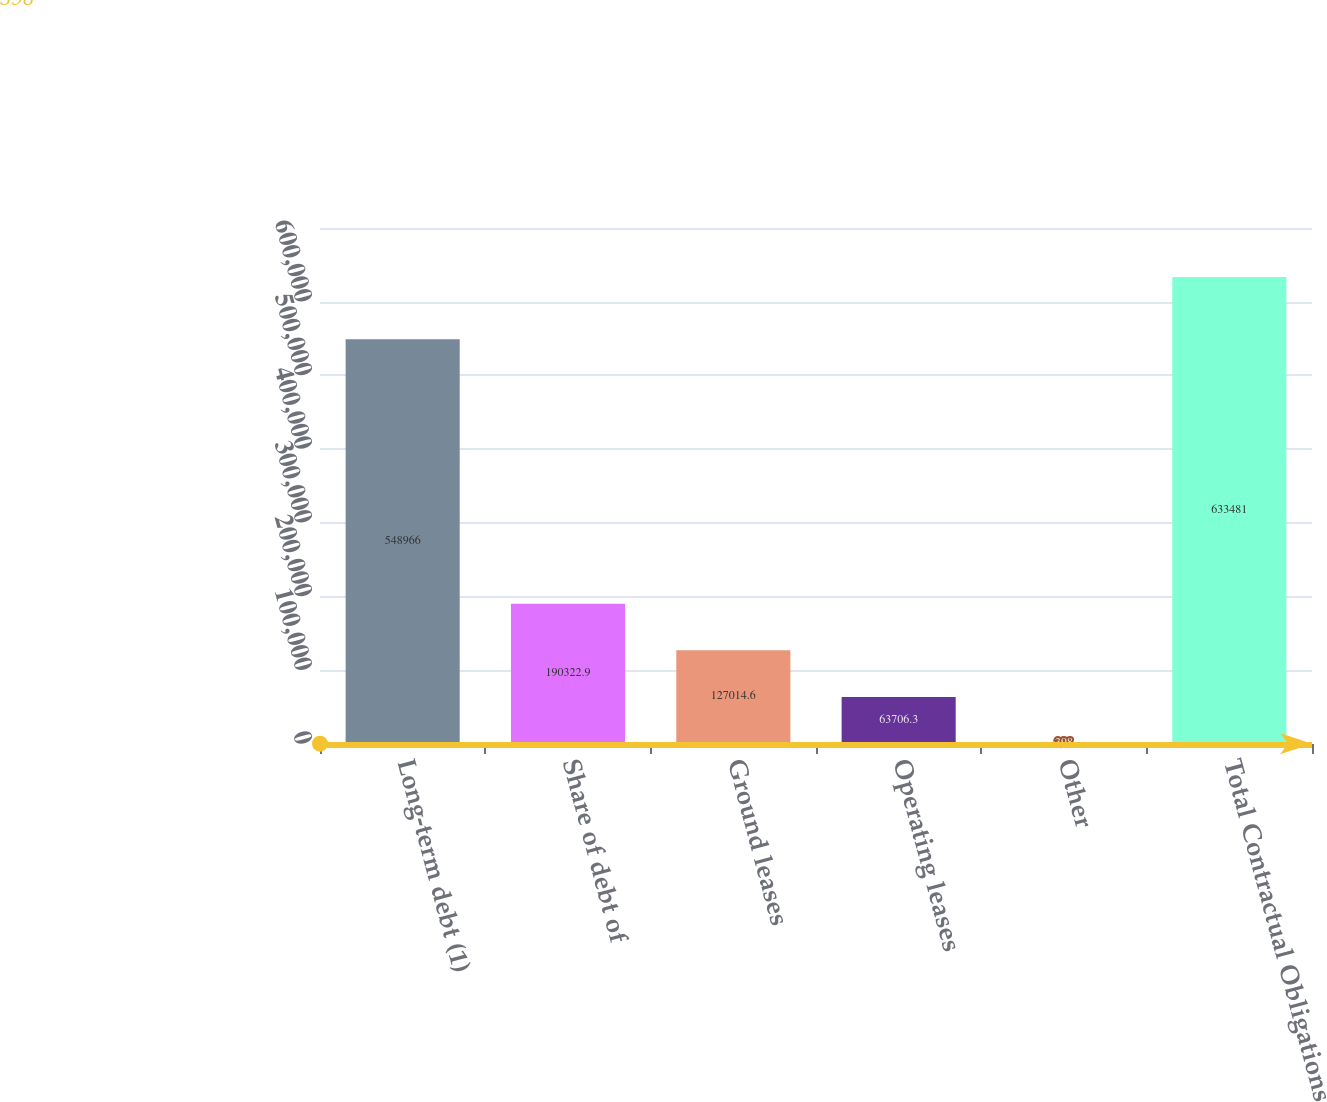<chart> <loc_0><loc_0><loc_500><loc_500><bar_chart><fcel>Long-term debt (1)<fcel>Share of debt of<fcel>Ground leases<fcel>Operating leases<fcel>Other<fcel>Total Contractual Obligations<nl><fcel>548966<fcel>190323<fcel>127015<fcel>63706.3<fcel>398<fcel>633481<nl></chart> 